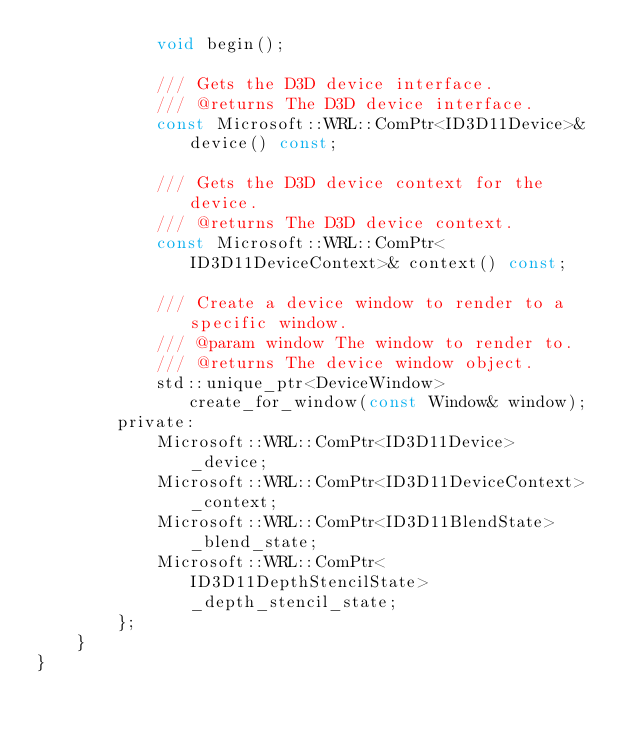<code> <loc_0><loc_0><loc_500><loc_500><_C_>            void begin();

            /// Gets the D3D device interface.
            /// @returns The D3D device interface.
            const Microsoft::WRL::ComPtr<ID3D11Device>& device() const;

            /// Gets the D3D device context for the device.
            /// @returns The D3D device context.
            const Microsoft::WRL::ComPtr<ID3D11DeviceContext>& context() const;

            /// Create a device window to render to a specific window.
            /// @param window The window to render to.
            /// @returns The device window object.
            std::unique_ptr<DeviceWindow> create_for_window(const Window& window);
        private:
            Microsoft::WRL::ComPtr<ID3D11Device>        _device;
            Microsoft::WRL::ComPtr<ID3D11DeviceContext> _context;
            Microsoft::WRL::ComPtr<ID3D11BlendState>    _blend_state;
            Microsoft::WRL::ComPtr<ID3D11DepthStencilState> _depth_stencil_state;
        };
    }
}
</code> 